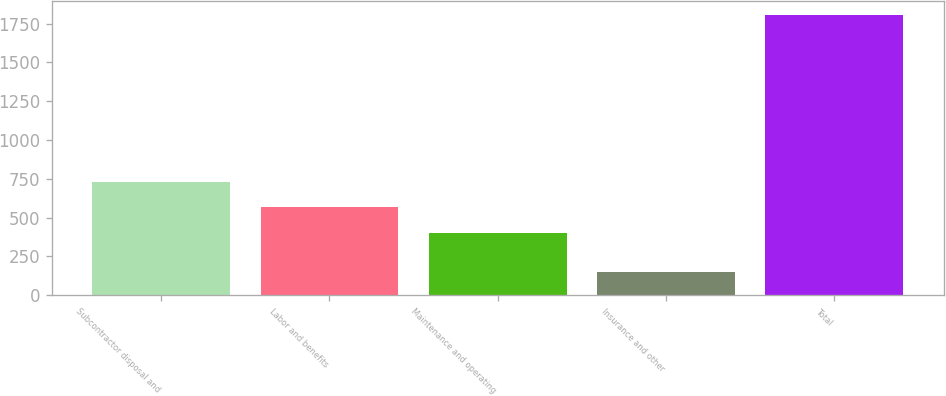Convert chart. <chart><loc_0><loc_0><loc_500><loc_500><bar_chart><fcel>Subcontractor disposal and<fcel>Labor and benefits<fcel>Maintenance and operating<fcel>Insurance and other<fcel>Total<nl><fcel>731.88<fcel>566.54<fcel>401.2<fcel>150.5<fcel>1803.9<nl></chart> 